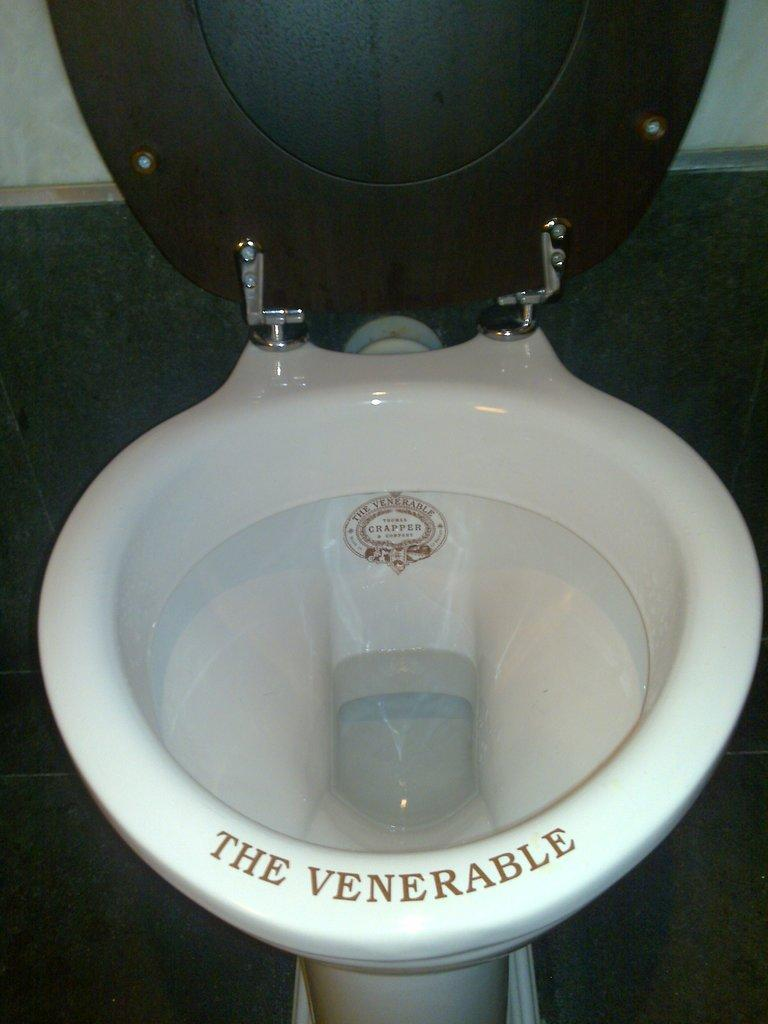<image>
Describe the image concisely. A toilet with the words "the venerable" on it 